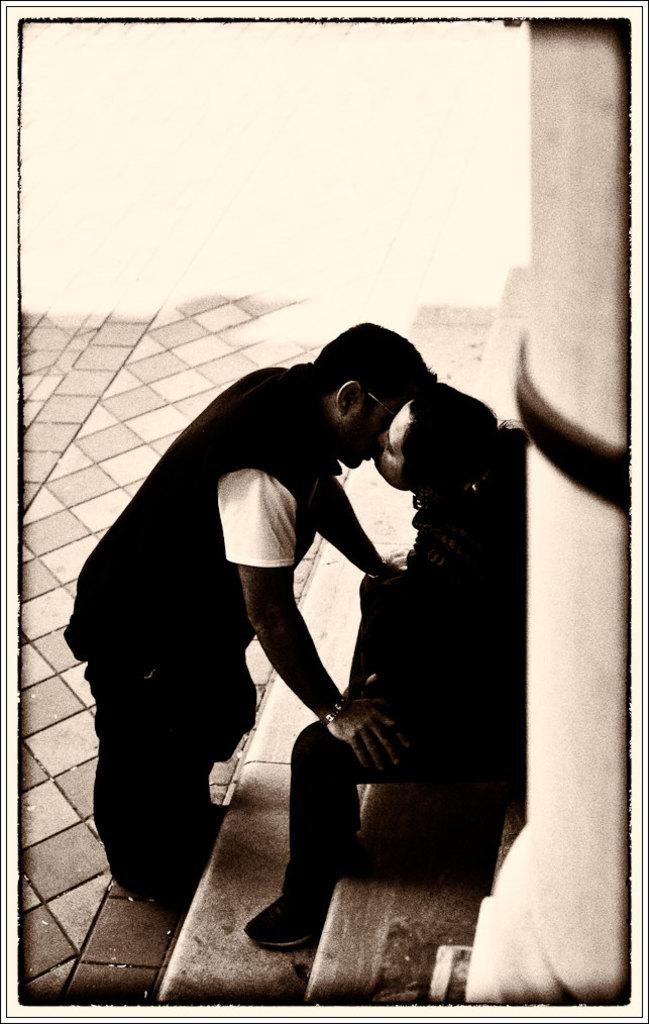Who is the main subject on the right side of the image? There is a girl sitting on the right side of the image. Who is the main subject on the left side of the image? There is a boy standing on the left side of the image. What is the boy doing in the image? The boy is kissing the girl. What type of apple is being used as a hat in the image? There is no apple or hat present in the image. What news is being discussed between the girl and the boy in the image? There is no discussion or news being mentioned in the image; the boy is kissing the girl. 